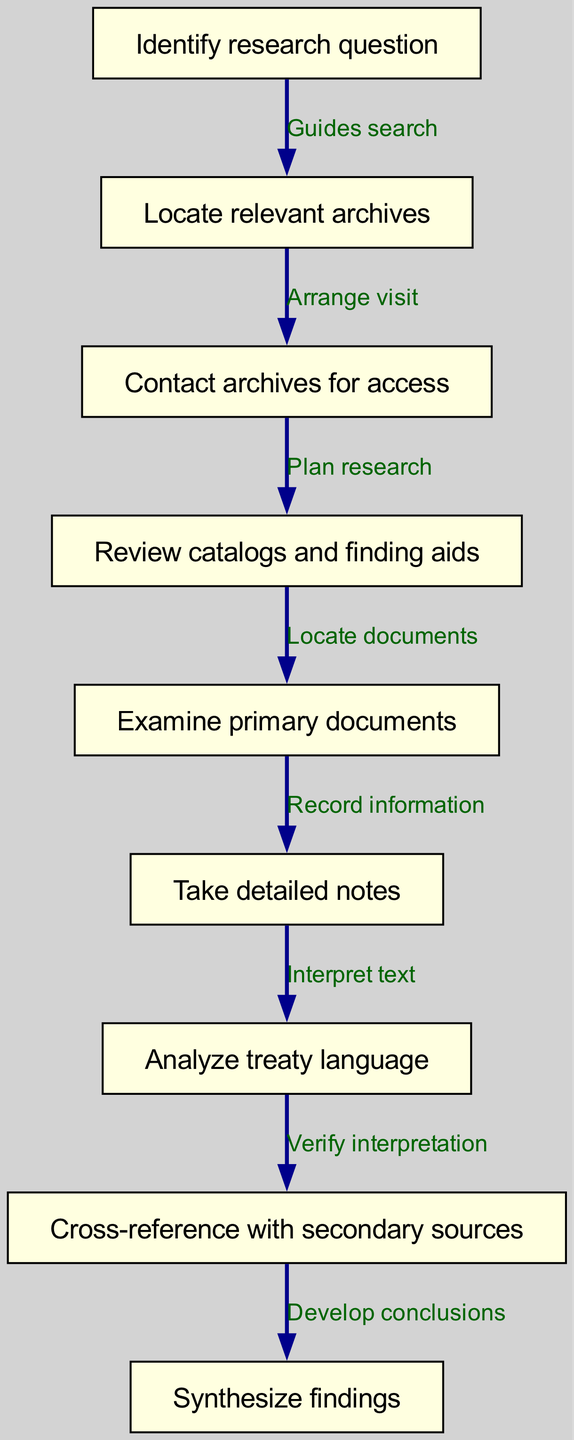What is the first step in the research process? According to the diagram, the first node is "Identify research question," which indicates the starting point of the archival research process.
Answer: Identify research question How many main steps are present in the diagram? The diagram contains nine nodes detailing the process, each representing a unique step in the archival research procedure.
Answer: Nine What does the edge from node 5 to node 6 indicate? The edge from node 5, which is "Examine primary documents," to node 6, "Take detailed notes," indicates that after examining the documents, the next logical step is to record the information gathered.
Answer: Record information Which step involves reviewing catalogs? The node labeled "Review catalogs and finding aids" specifically describes the process of examining catalogs to locate documents relevant to the research.
Answer: Review catalogs and finding aids What is the connection between analyzing treaty language and cross-referencing secondary sources? The edge in the diagram from node 7, "Analyze treaty language," to node 8, "Cross-reference with secondary sources," shows that after analyzing the language of the treaties, the researcher verifies their interpretations by comparing them with secondary sources.
Answer: Verify interpretation Which step comes immediately after locating archives? The diagram indicates that after "Locate relevant archives," the next step is to "Contact archives for access," which suggests that researchers must reach out to the archives to arrange for use of their resources.
Answer: Contact archives for access What is the final outcome of this research process? The last node in the flow chart is "Synthesize findings," which represents the culmination of the research where all the gathered information is compiled to form conclusions about the trade treaties.
Answer: Synthesize findings In what order do the first three steps occur? The first three steps flow from identifying the research question to locating relevant archives and then contacting those archives for access, creating a clear progression in the research process.
Answer: Identify research question, Locate relevant archives, Contact archives for access What is the purpose of taking detailed notes? The step "Take detailed notes" is intended to record the information extracted from primary documents, ensuring that valuable insights are not lost during the research process.
Answer: Record information 